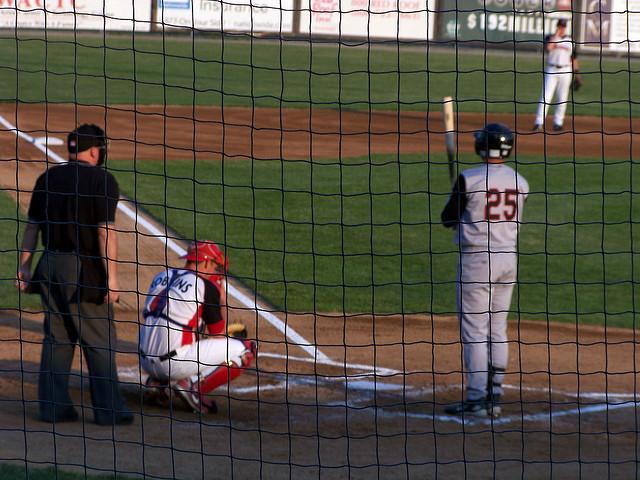What is the number of the man at bat?
Short answer required. 25. Is the batter swinging left or right handed?
Keep it brief. Left. Who is holding a baseball bat?
Keep it brief. Batter. What color shirt is the umpire wearing?
Keep it brief. Black. 